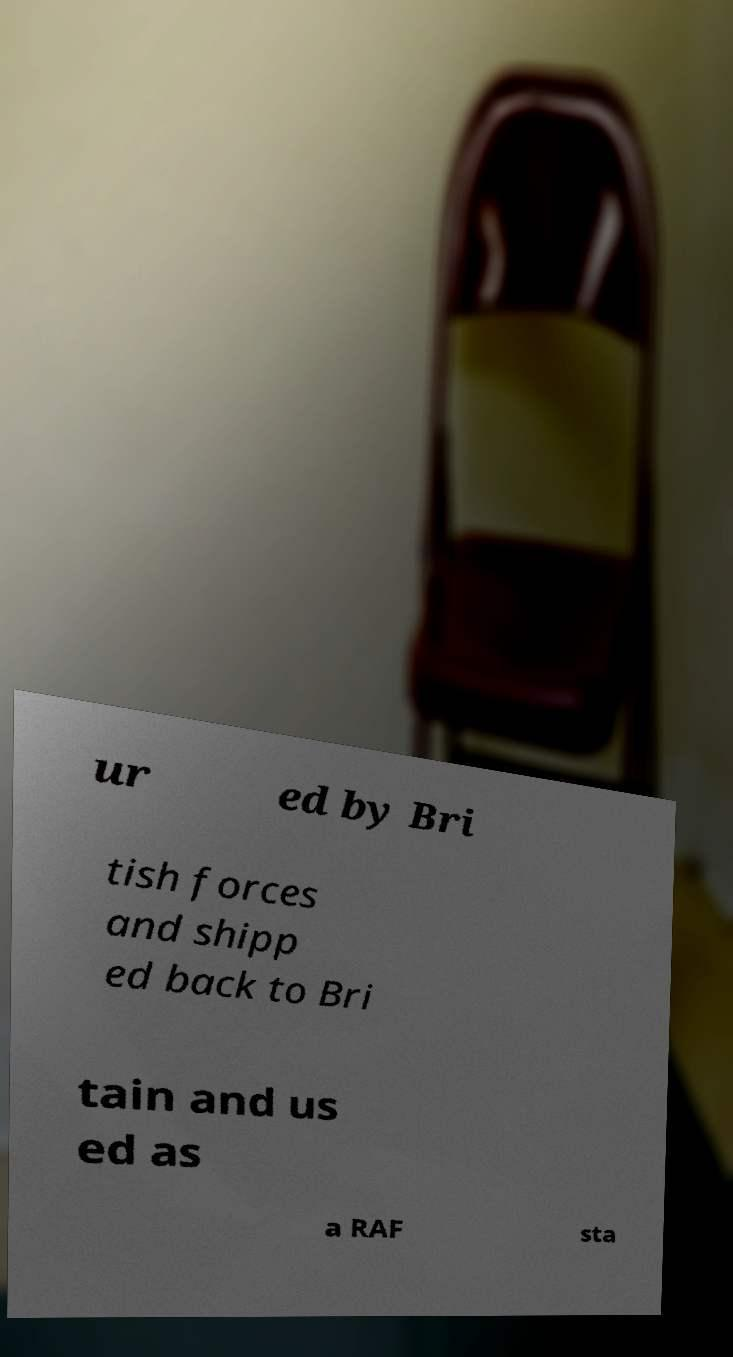What messages or text are displayed in this image? I need them in a readable, typed format. ur ed by Bri tish forces and shipp ed back to Bri tain and us ed as a RAF sta 